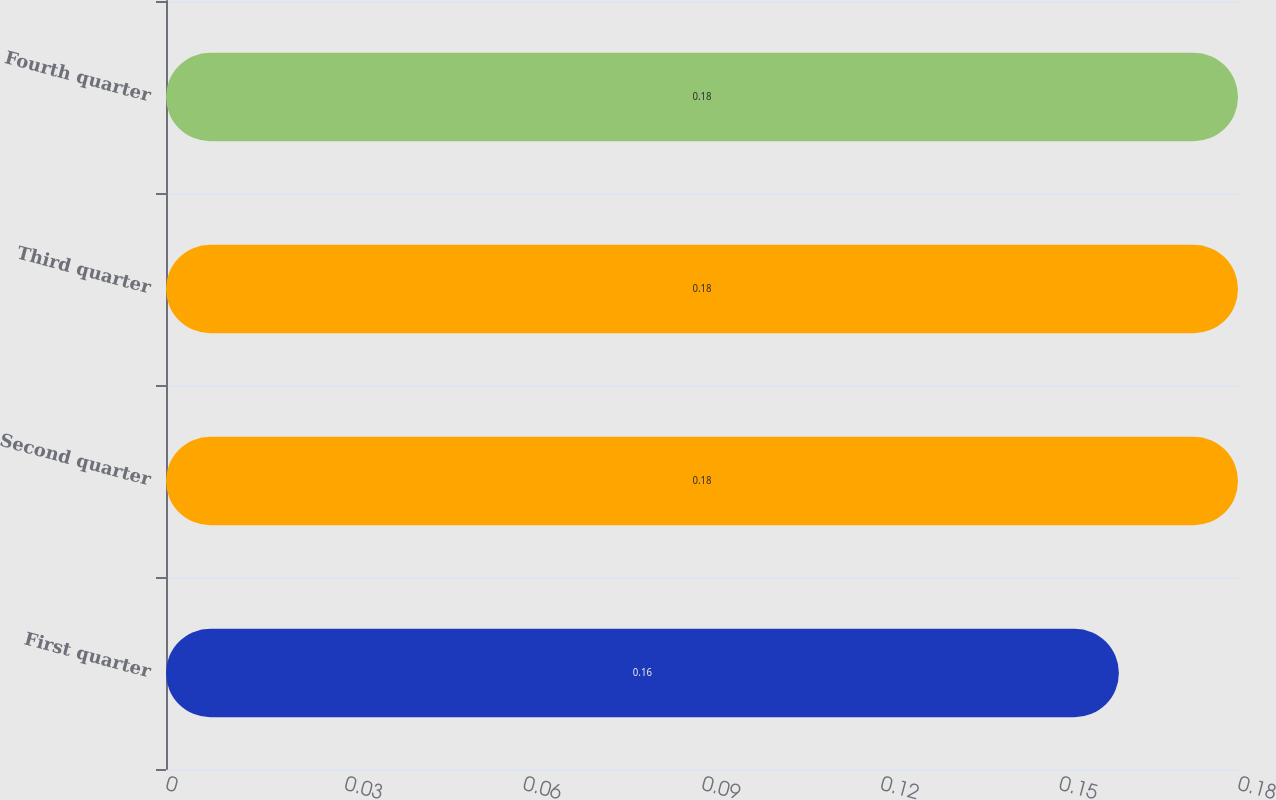Convert chart. <chart><loc_0><loc_0><loc_500><loc_500><bar_chart><fcel>First quarter<fcel>Second quarter<fcel>Third quarter<fcel>Fourth quarter<nl><fcel>0.16<fcel>0.18<fcel>0.18<fcel>0.18<nl></chart> 